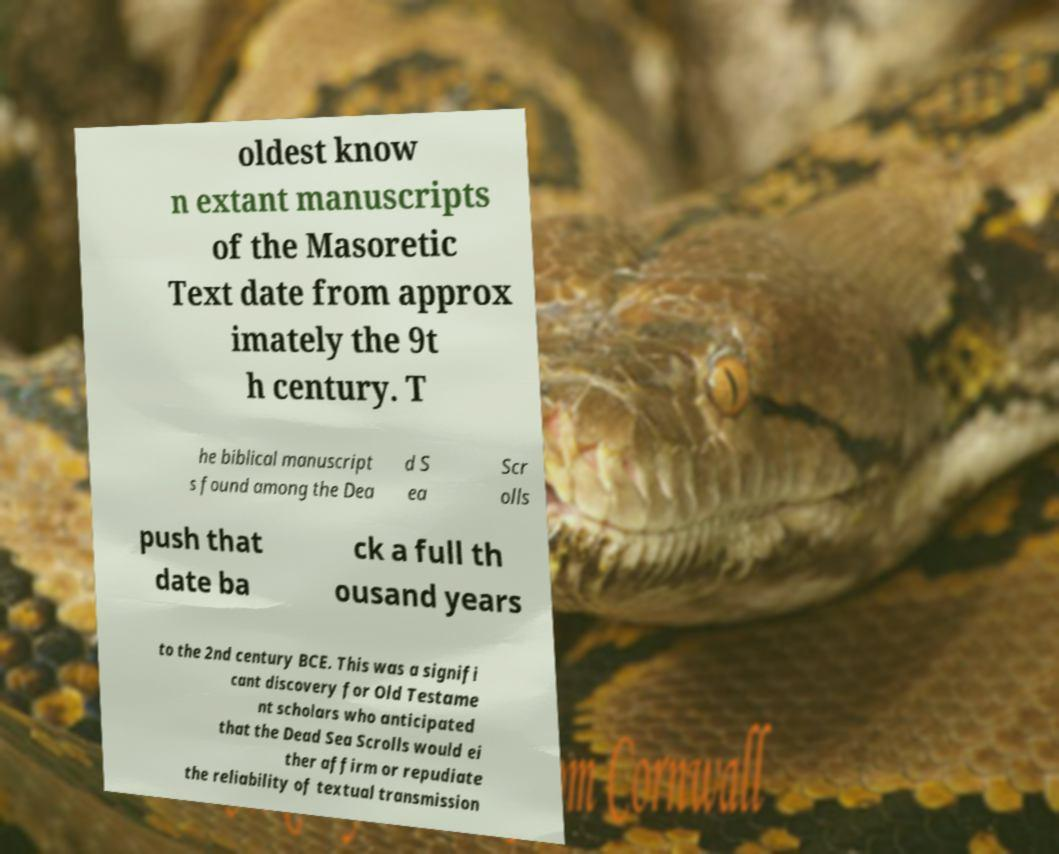Can you read and provide the text displayed in the image?This photo seems to have some interesting text. Can you extract and type it out for me? oldest know n extant manuscripts of the Masoretic Text date from approx imately the 9t h century. T he biblical manuscript s found among the Dea d S ea Scr olls push that date ba ck a full th ousand years to the 2nd century BCE. This was a signifi cant discovery for Old Testame nt scholars who anticipated that the Dead Sea Scrolls would ei ther affirm or repudiate the reliability of textual transmission 